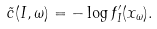<formula> <loc_0><loc_0><loc_500><loc_500>\tilde { c } ( I , \omega ) = - \log f ^ { \prime } _ { I } ( x _ { \omega } ) .</formula> 